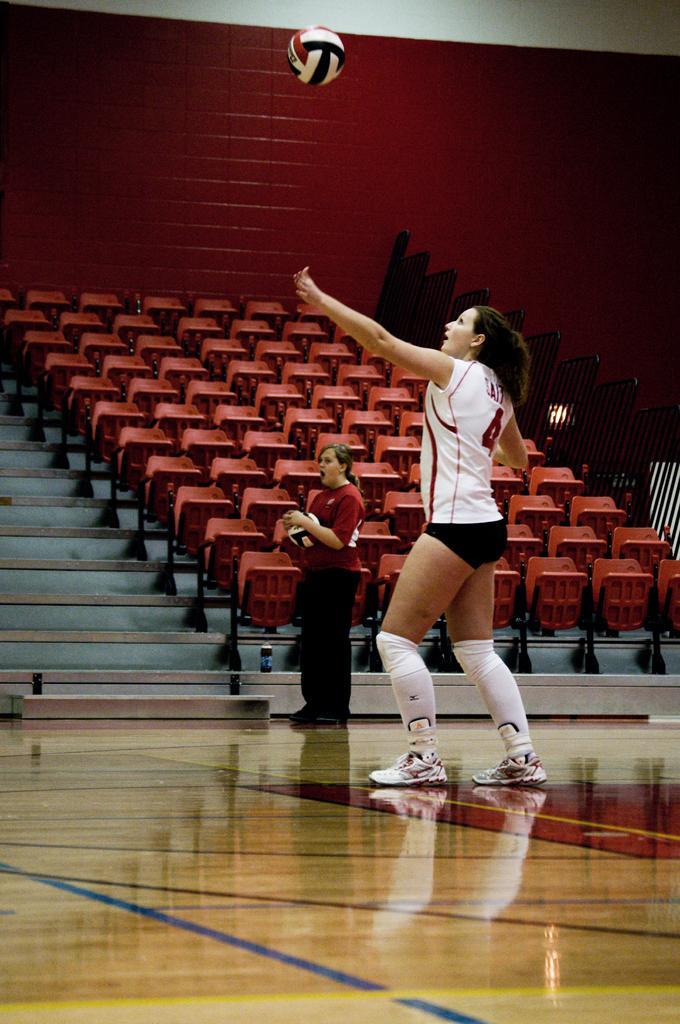Describe this image in one or two sentences. In the image we can see two women wearing clothes and shoes. Here we can see two valley balls, chairs and stairs. We can even see volleyball court, fence and the wall. 